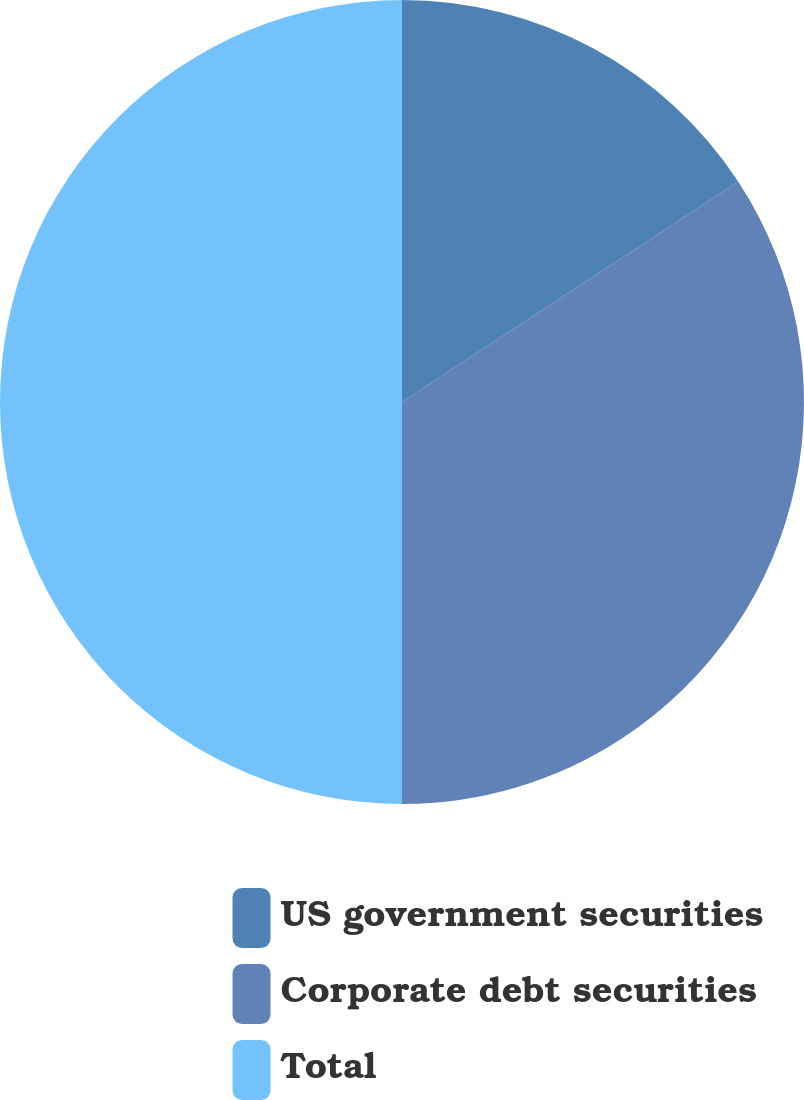Convert chart. <chart><loc_0><loc_0><loc_500><loc_500><pie_chart><fcel>US government securities<fcel>Corporate debt securities<fcel>Total<nl><fcel>15.77%<fcel>34.23%<fcel>50.0%<nl></chart> 